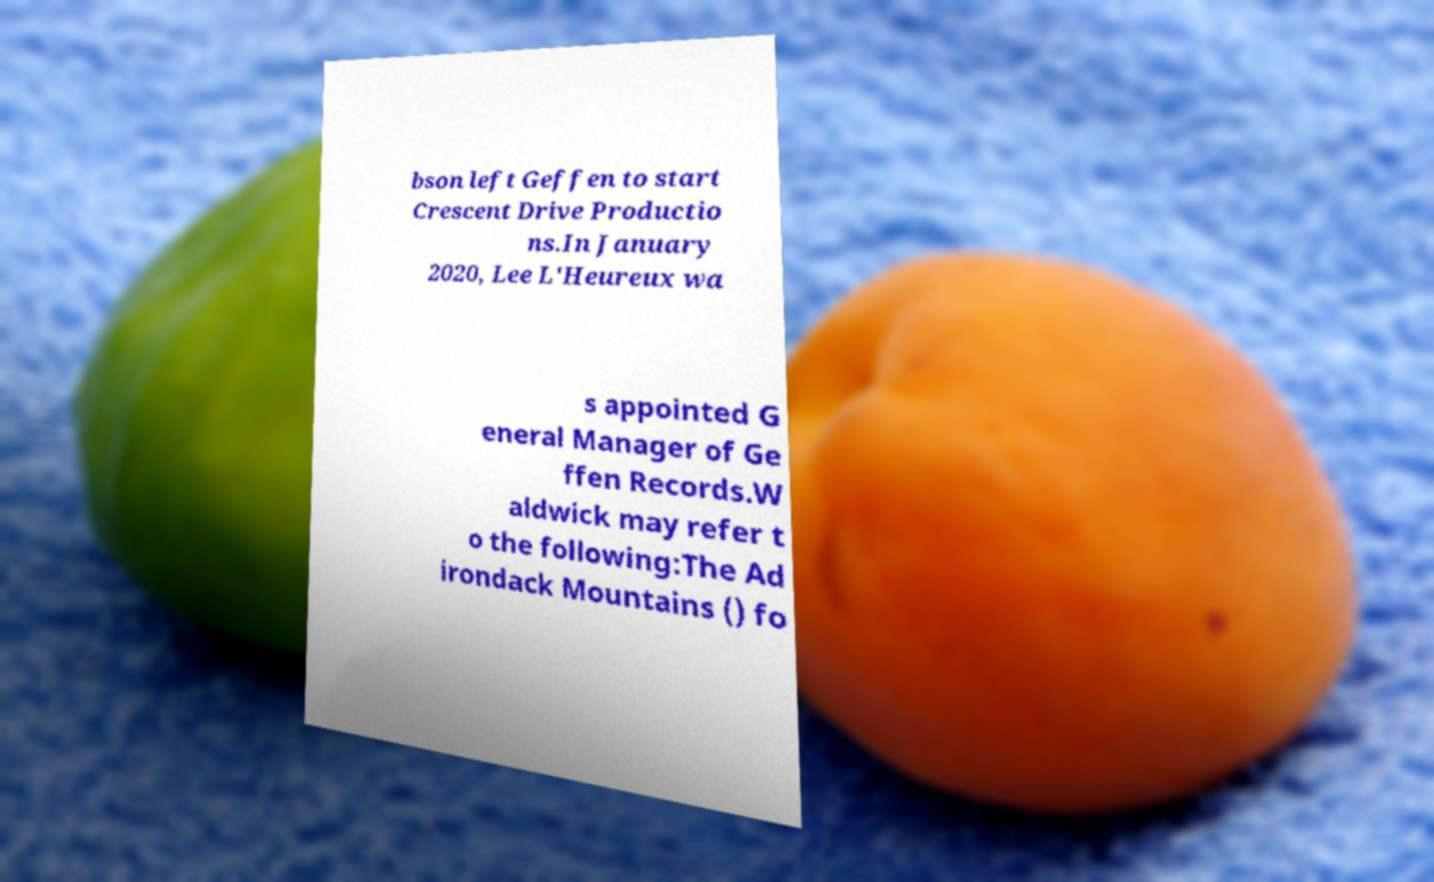Please read and relay the text visible in this image. What does it say? bson left Geffen to start Crescent Drive Productio ns.In January 2020, Lee L'Heureux wa s appointed G eneral Manager of Ge ffen Records.W aldwick may refer t o the following:The Ad irondack Mountains () fo 